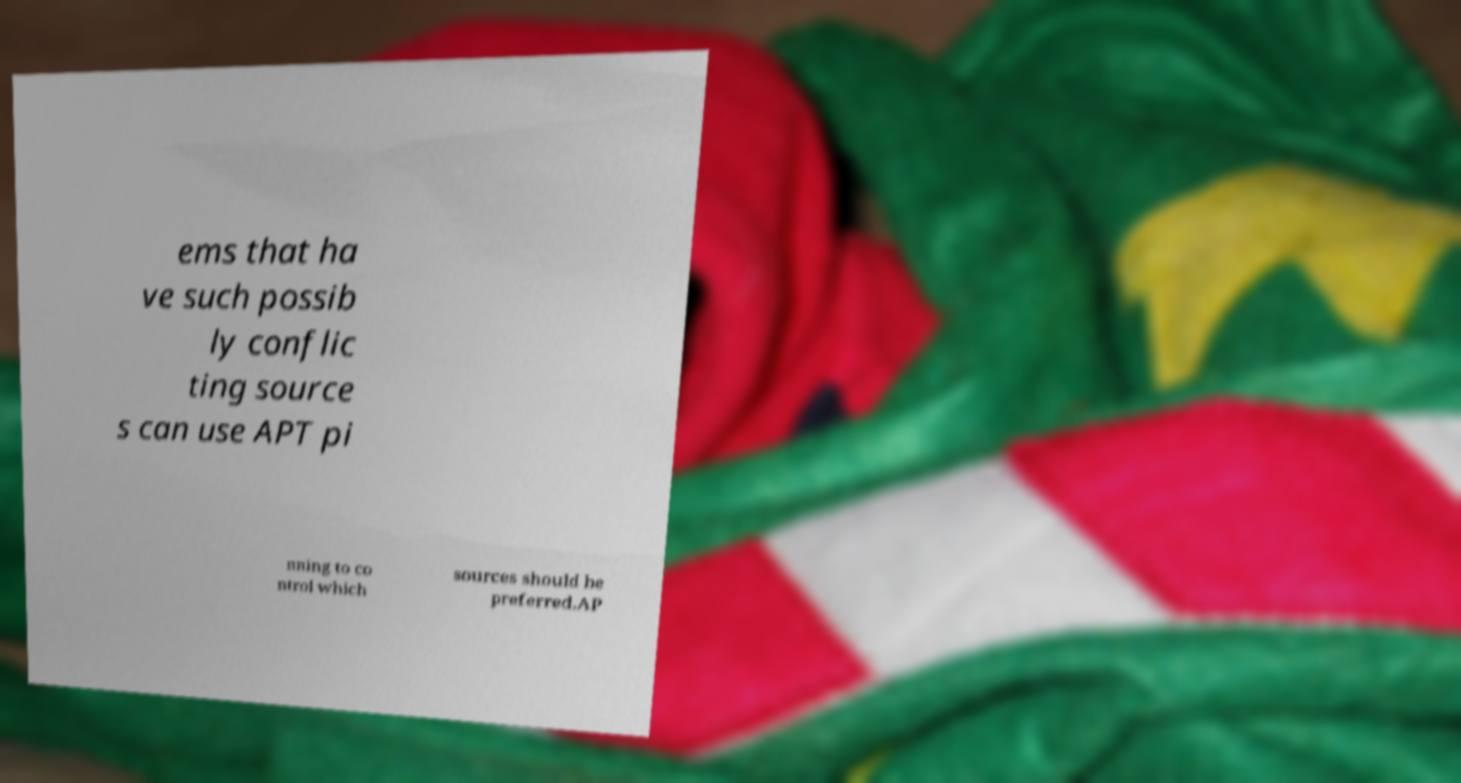Could you assist in decoding the text presented in this image and type it out clearly? ems that ha ve such possib ly conflic ting source s can use APT pi nning to co ntrol which sources should be preferred.AP 